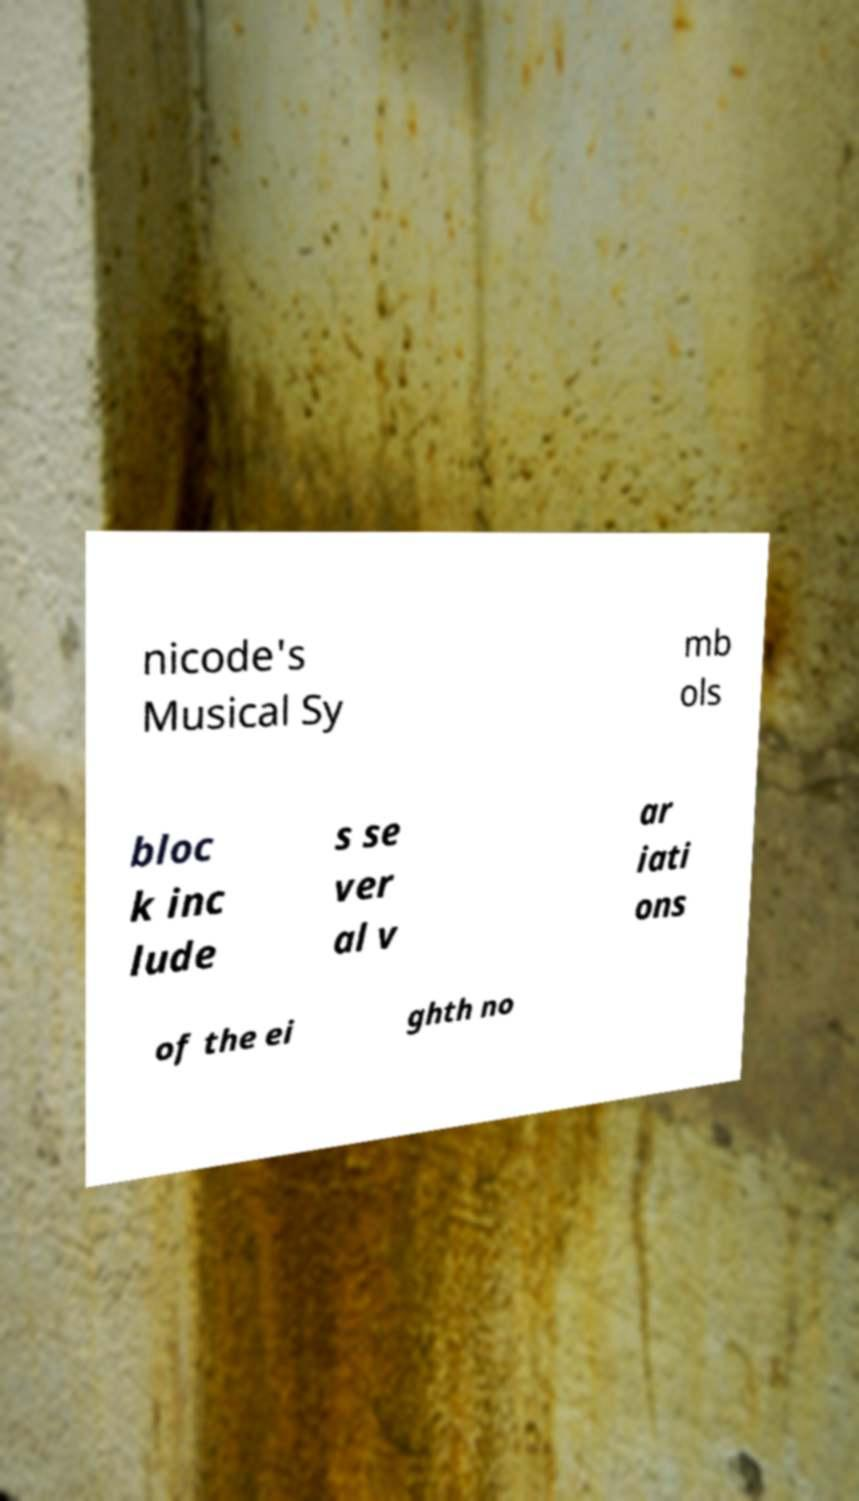Please identify and transcribe the text found in this image. nicode's Musical Sy mb ols bloc k inc lude s se ver al v ar iati ons of the ei ghth no 